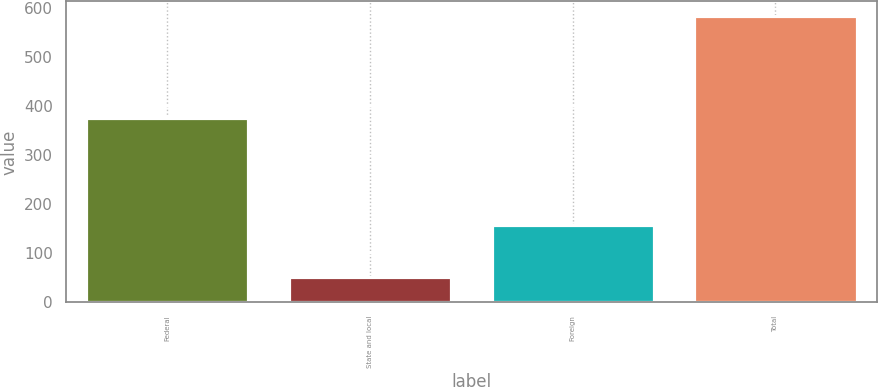Convert chart to OTSL. <chart><loc_0><loc_0><loc_500><loc_500><bar_chart><fcel>Federal<fcel>State and local<fcel>Foreign<fcel>Total<nl><fcel>375<fcel>52<fcel>157<fcel>584<nl></chart> 